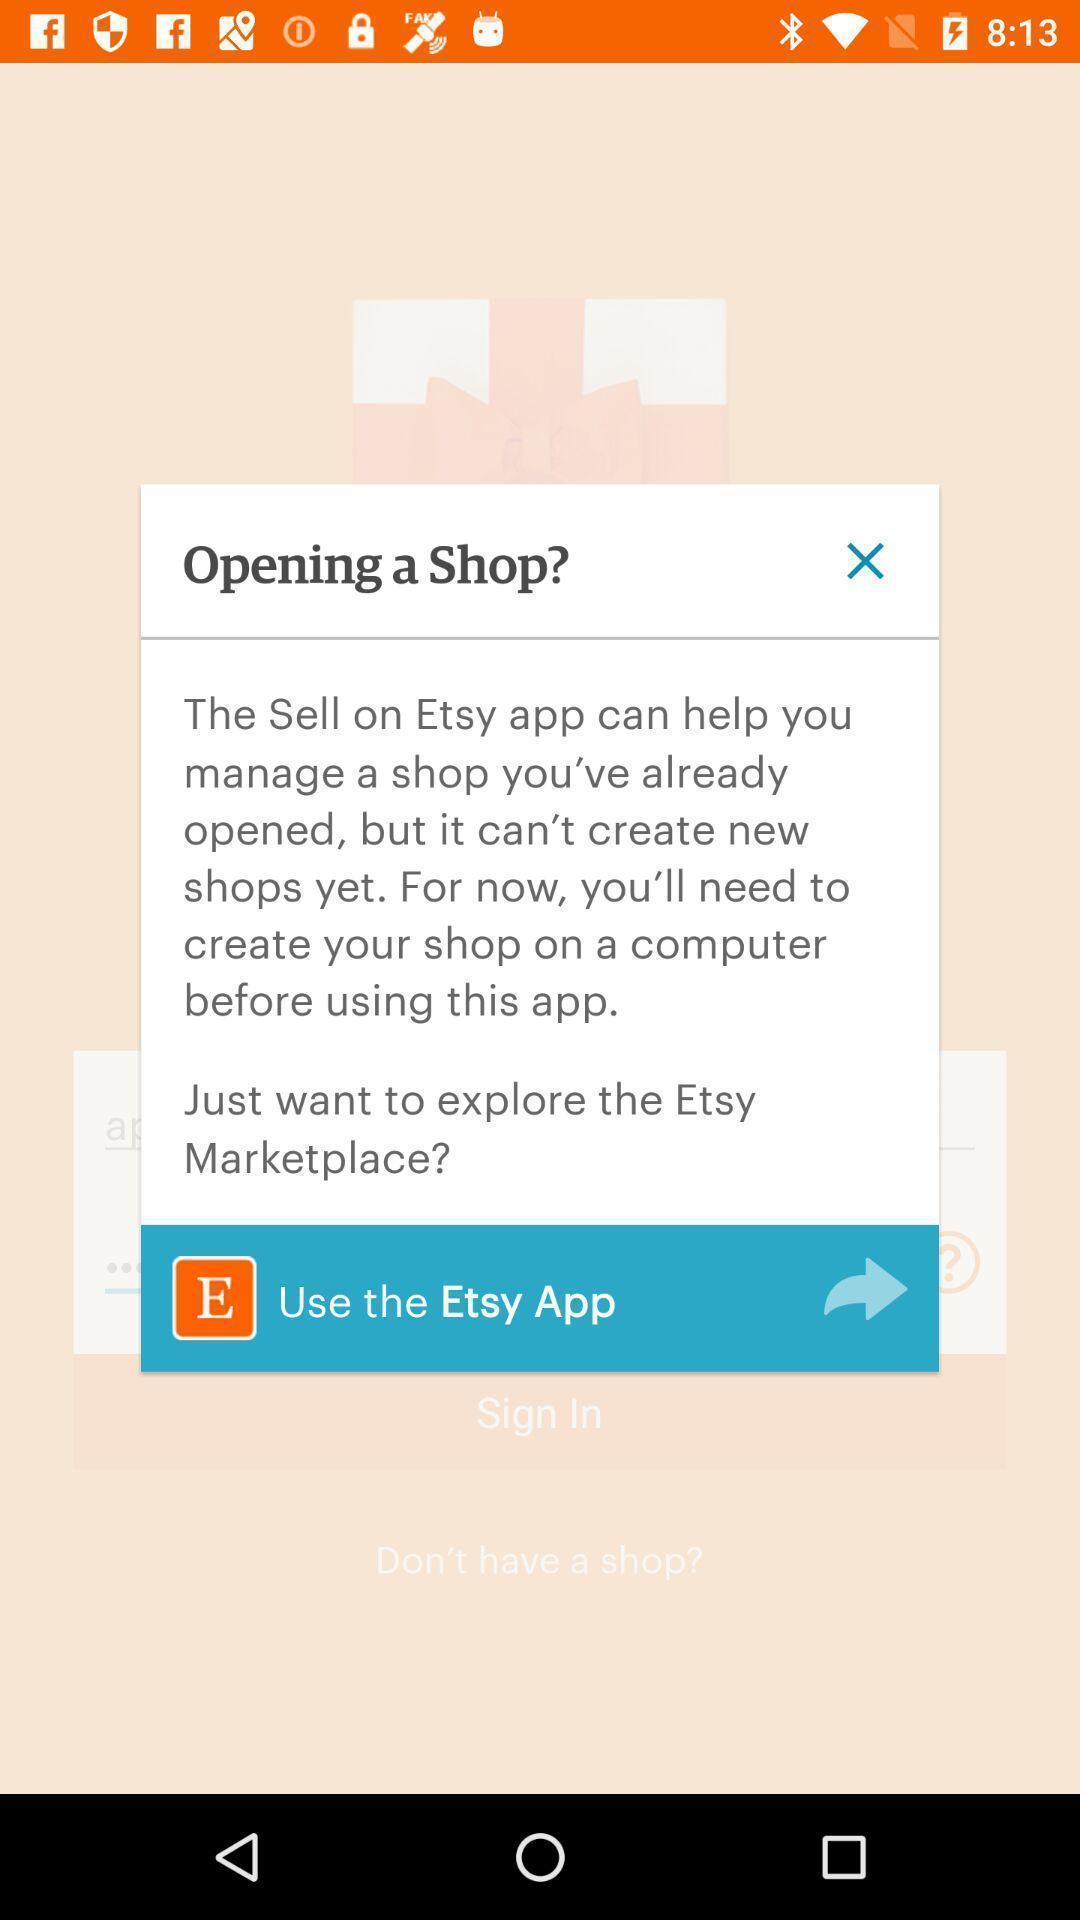Explain what's happening in this screen capture. Popup shows information about shop marketing app. 